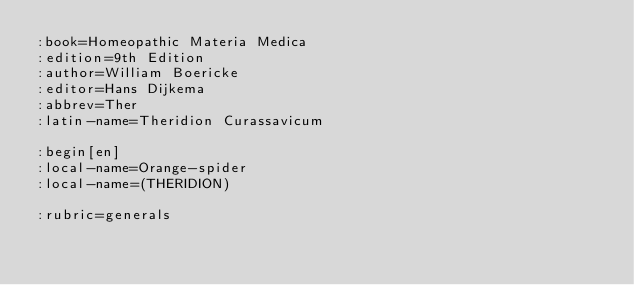<code> <loc_0><loc_0><loc_500><loc_500><_ObjectiveC_>:book=Homeopathic Materia Medica
:edition=9th Edition
:author=William Boericke
:editor=Hans Dijkema
:abbrev=Ther
:latin-name=Theridion Curassavicum

:begin[en]
:local-name=Orange-spider
:local-name=(THERIDION)

:rubric=generals</code> 